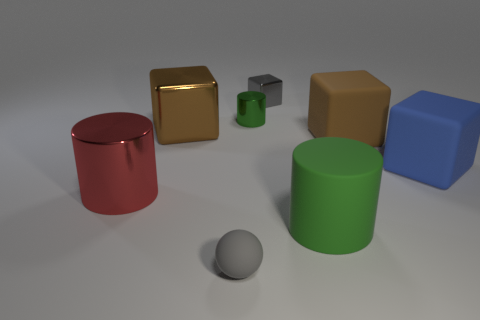Are there more big metallic objects in front of the large brown matte object than tiny gray metallic cubes that are in front of the brown shiny block?
Your answer should be very brief. Yes. What number of cylinders are either small green metal objects or red shiny things?
Make the answer very short. 2. Is the shape of the brown object to the left of the ball the same as  the small gray shiny thing?
Your answer should be compact. Yes. The large shiny cylinder is what color?
Offer a terse response. Red. There is a small shiny thing that is the same shape as the large red metal object; what is its color?
Offer a very short reply. Green. What number of brown metallic objects are the same shape as the gray matte thing?
Offer a terse response. 0. What number of things are either small metal cubes or brown blocks right of the small rubber sphere?
Keep it short and to the point. 2. There is a big rubber cylinder; does it have the same color as the metal cylinder that is in front of the brown rubber block?
Make the answer very short. No. There is a cylinder that is both in front of the big blue cube and left of the gray shiny object; what is its size?
Make the answer very short. Large. Are there any rubber blocks left of the red metallic object?
Your answer should be compact. No. 